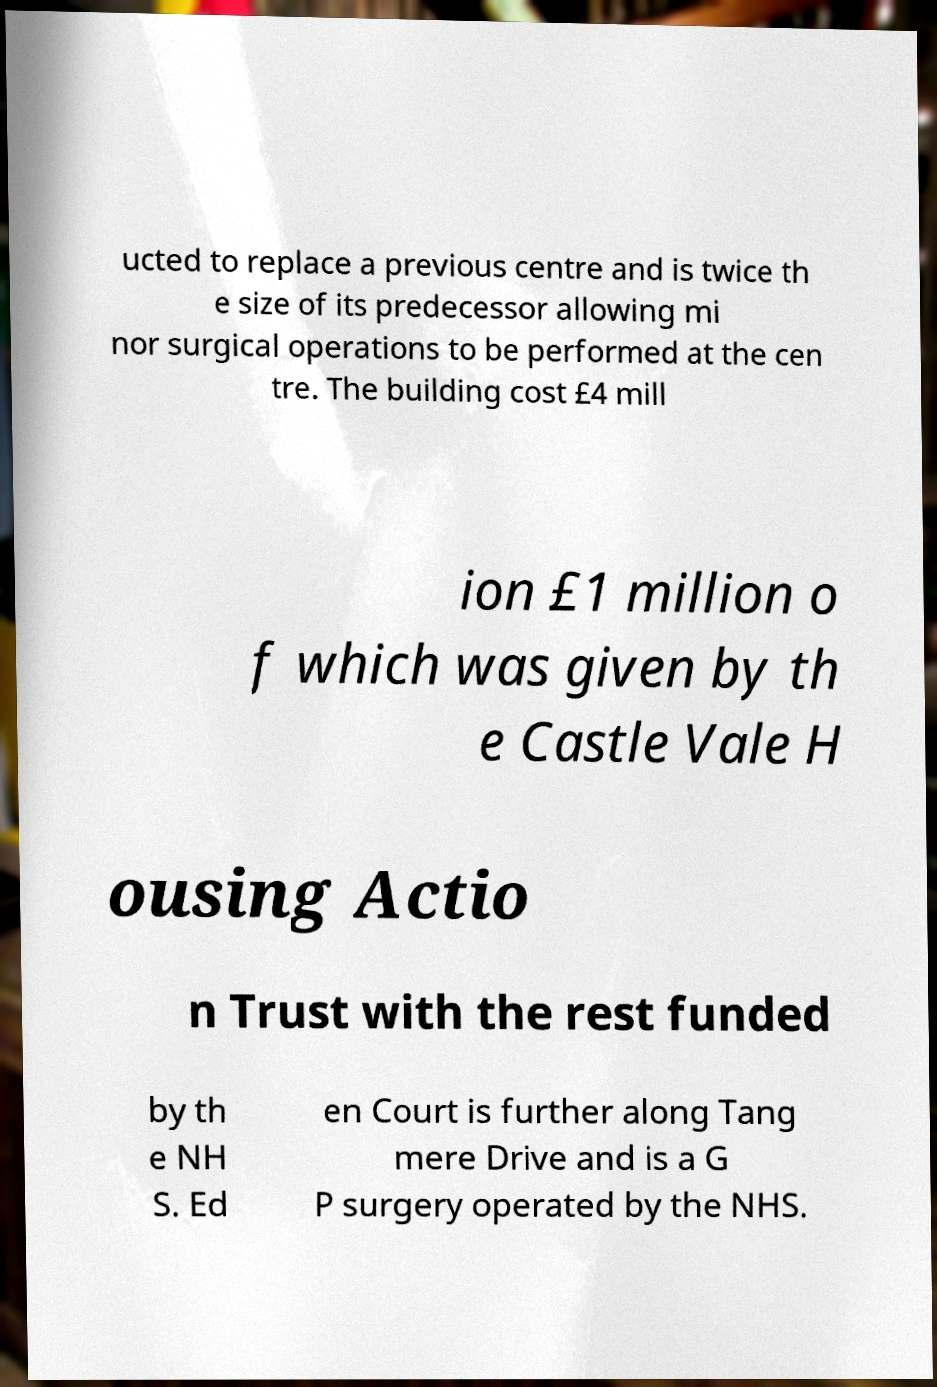I need the written content from this picture converted into text. Can you do that? ucted to replace a previous centre and is twice th e size of its predecessor allowing mi nor surgical operations to be performed at the cen tre. The building cost £4 mill ion £1 million o f which was given by th e Castle Vale H ousing Actio n Trust with the rest funded by th e NH S. Ed en Court is further along Tang mere Drive and is a G P surgery operated by the NHS. 